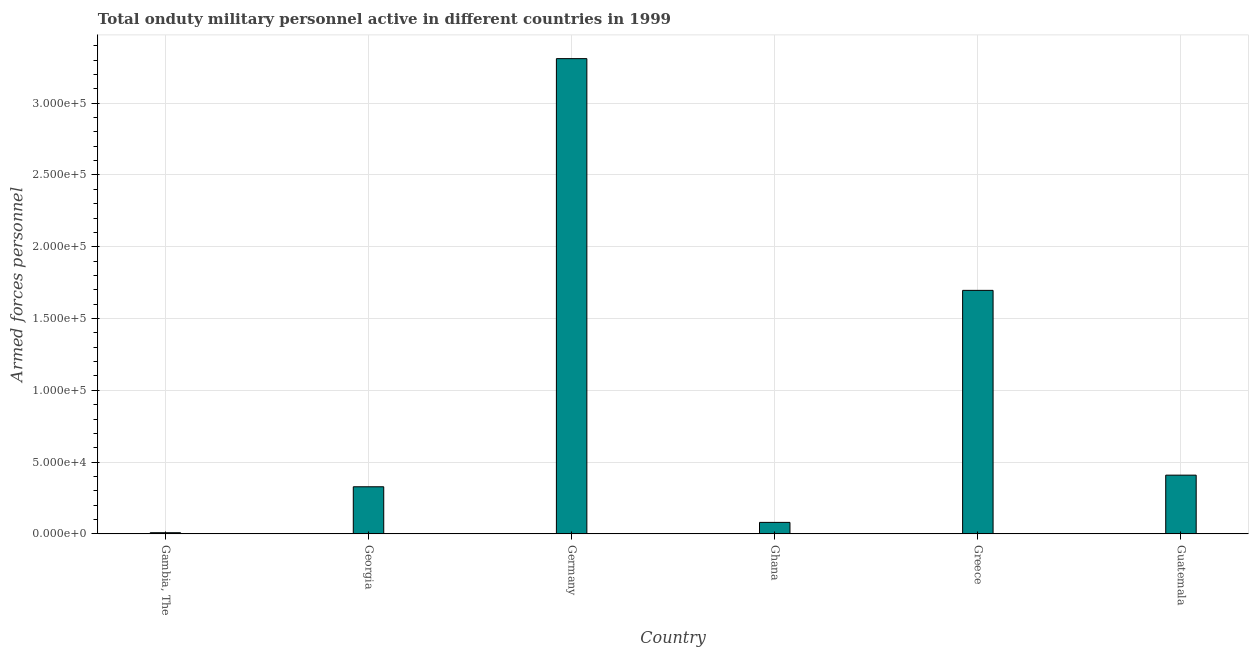Does the graph contain any zero values?
Provide a short and direct response. No. What is the title of the graph?
Offer a terse response. Total onduty military personnel active in different countries in 1999. What is the label or title of the Y-axis?
Ensure brevity in your answer.  Armed forces personnel. What is the number of armed forces personnel in Ghana?
Your answer should be very brief. 8000. Across all countries, what is the maximum number of armed forces personnel?
Provide a short and direct response. 3.31e+05. Across all countries, what is the minimum number of armed forces personnel?
Ensure brevity in your answer.  800. In which country was the number of armed forces personnel minimum?
Offer a very short reply. Gambia, The. What is the sum of the number of armed forces personnel?
Make the answer very short. 5.83e+05. What is the difference between the number of armed forces personnel in Germany and Guatemala?
Your answer should be very brief. 2.90e+05. What is the average number of armed forces personnel per country?
Offer a terse response. 9.72e+04. What is the median number of armed forces personnel?
Provide a succinct answer. 3.68e+04. In how many countries, is the number of armed forces personnel greater than 190000 ?
Provide a short and direct response. 1. Is the number of armed forces personnel in Ghana less than that in Guatemala?
Ensure brevity in your answer.  Yes. Is the difference between the number of armed forces personnel in Georgia and Guatemala greater than the difference between any two countries?
Provide a succinct answer. No. What is the difference between the highest and the second highest number of armed forces personnel?
Offer a very short reply. 1.61e+05. Is the sum of the number of armed forces personnel in Germany and Ghana greater than the maximum number of armed forces personnel across all countries?
Provide a succinct answer. Yes. What is the difference between the highest and the lowest number of armed forces personnel?
Keep it short and to the point. 3.30e+05. In how many countries, is the number of armed forces personnel greater than the average number of armed forces personnel taken over all countries?
Give a very brief answer. 2. How many bars are there?
Your response must be concise. 6. Are all the bars in the graph horizontal?
Provide a succinct answer. No. Are the values on the major ticks of Y-axis written in scientific E-notation?
Your answer should be very brief. Yes. What is the Armed forces personnel in Gambia, The?
Provide a short and direct response. 800. What is the Armed forces personnel in Georgia?
Offer a terse response. 3.28e+04. What is the Armed forces personnel in Germany?
Offer a very short reply. 3.31e+05. What is the Armed forces personnel in Ghana?
Provide a short and direct response. 8000. What is the Armed forces personnel of Greece?
Offer a very short reply. 1.70e+05. What is the Armed forces personnel of Guatemala?
Provide a succinct answer. 4.09e+04. What is the difference between the Armed forces personnel in Gambia, The and Georgia?
Your response must be concise. -3.20e+04. What is the difference between the Armed forces personnel in Gambia, The and Germany?
Ensure brevity in your answer.  -3.30e+05. What is the difference between the Armed forces personnel in Gambia, The and Ghana?
Offer a terse response. -7200. What is the difference between the Armed forces personnel in Gambia, The and Greece?
Keep it short and to the point. -1.69e+05. What is the difference between the Armed forces personnel in Gambia, The and Guatemala?
Give a very brief answer. -4.01e+04. What is the difference between the Armed forces personnel in Georgia and Germany?
Your response must be concise. -2.98e+05. What is the difference between the Armed forces personnel in Georgia and Ghana?
Offer a very short reply. 2.48e+04. What is the difference between the Armed forces personnel in Georgia and Greece?
Make the answer very short. -1.37e+05. What is the difference between the Armed forces personnel in Georgia and Guatemala?
Give a very brief answer. -8100. What is the difference between the Armed forces personnel in Germany and Ghana?
Provide a succinct answer. 3.23e+05. What is the difference between the Armed forces personnel in Germany and Greece?
Provide a short and direct response. 1.61e+05. What is the difference between the Armed forces personnel in Germany and Guatemala?
Your answer should be compact. 2.90e+05. What is the difference between the Armed forces personnel in Ghana and Greece?
Your answer should be compact. -1.62e+05. What is the difference between the Armed forces personnel in Ghana and Guatemala?
Keep it short and to the point. -3.29e+04. What is the difference between the Armed forces personnel in Greece and Guatemala?
Provide a succinct answer. 1.29e+05. What is the ratio of the Armed forces personnel in Gambia, The to that in Georgia?
Provide a succinct answer. 0.02. What is the ratio of the Armed forces personnel in Gambia, The to that in Germany?
Your response must be concise. 0. What is the ratio of the Armed forces personnel in Gambia, The to that in Ghana?
Ensure brevity in your answer.  0.1. What is the ratio of the Armed forces personnel in Gambia, The to that in Greece?
Give a very brief answer. 0.01. What is the ratio of the Armed forces personnel in Gambia, The to that in Guatemala?
Keep it short and to the point. 0.02. What is the ratio of the Armed forces personnel in Georgia to that in Germany?
Your answer should be very brief. 0.1. What is the ratio of the Armed forces personnel in Georgia to that in Ghana?
Provide a succinct answer. 4.1. What is the ratio of the Armed forces personnel in Georgia to that in Greece?
Offer a terse response. 0.19. What is the ratio of the Armed forces personnel in Georgia to that in Guatemala?
Your answer should be compact. 0.8. What is the ratio of the Armed forces personnel in Germany to that in Ghana?
Provide a short and direct response. 41.38. What is the ratio of the Armed forces personnel in Germany to that in Greece?
Keep it short and to the point. 1.95. What is the ratio of the Armed forces personnel in Germany to that in Guatemala?
Your response must be concise. 8.09. What is the ratio of the Armed forces personnel in Ghana to that in Greece?
Offer a terse response. 0.05. What is the ratio of the Armed forces personnel in Ghana to that in Guatemala?
Keep it short and to the point. 0.2. What is the ratio of the Armed forces personnel in Greece to that in Guatemala?
Give a very brief answer. 4.15. 